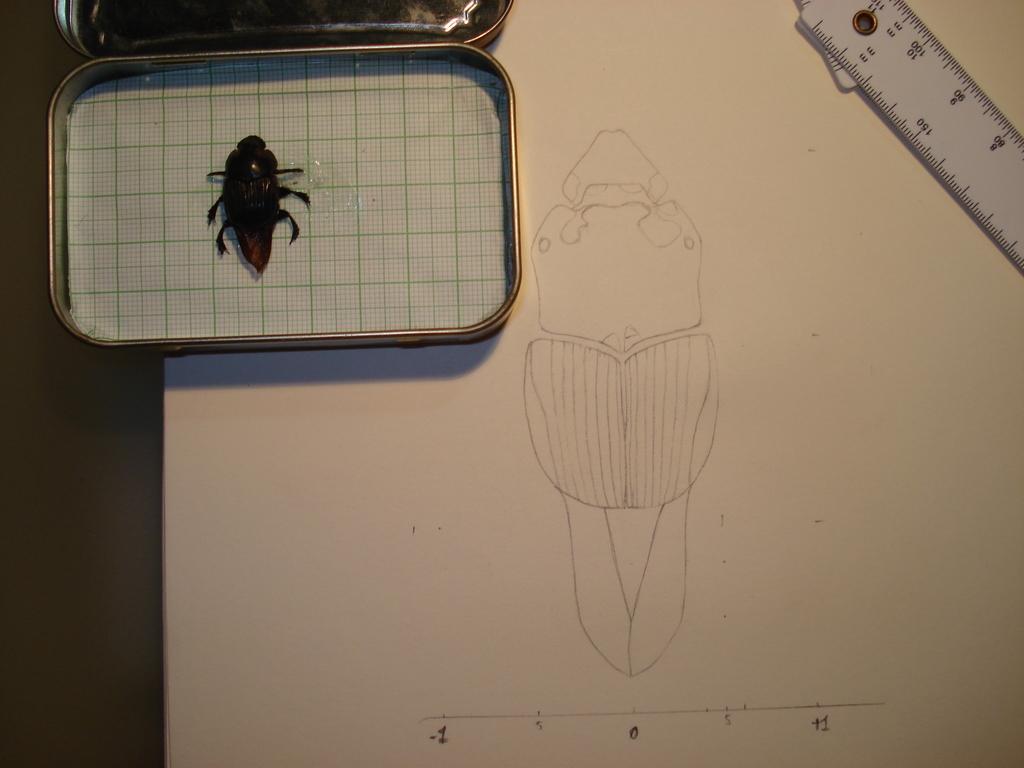Describe this image in one or two sentences. In this image, we can see a table. In this image, on the left side top, we can see a box which is opened, in the box, we can see paper and an insect. On the right side top of the table, we can see a scale. In the middle of the image of the table, we can see a paper with some painting on it. 